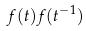Convert formula to latex. <formula><loc_0><loc_0><loc_500><loc_500>f ( t ) f ( t ^ { - 1 } )</formula> 